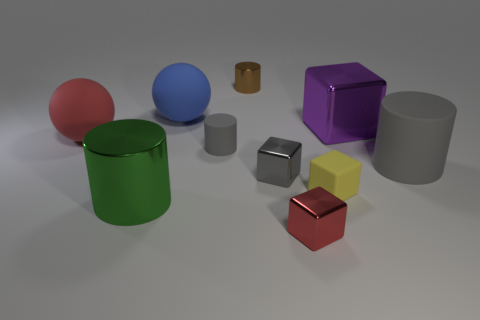What is the material of the other small thing that is the same shape as the brown shiny object?
Your response must be concise. Rubber. There is a shiny cylinder that is behind the purple metal object; does it have the same size as the yellow matte object?
Ensure brevity in your answer.  Yes. There is a big shiny object left of the matte cylinder that is to the left of the tiny red shiny block; what number of small gray objects are on the right side of it?
Ensure brevity in your answer.  2. How big is the metallic block that is both in front of the red matte ball and right of the tiny gray metallic block?
Ensure brevity in your answer.  Small. What number of other things are the same shape as the red metallic object?
Give a very brief answer. 3. What number of big shiny cylinders are in front of the red rubber ball?
Provide a short and direct response. 1. Are there fewer gray rubber cylinders right of the gray shiny thing than big things that are on the left side of the large purple block?
Make the answer very short. Yes. There is a red thing left of the red object that is to the right of the matte object left of the large blue matte thing; what is its shape?
Ensure brevity in your answer.  Sphere. What shape is the big rubber thing that is both in front of the large blue matte thing and to the right of the green metallic thing?
Offer a terse response. Cylinder. Is there a small gray object made of the same material as the yellow thing?
Keep it short and to the point. Yes. 